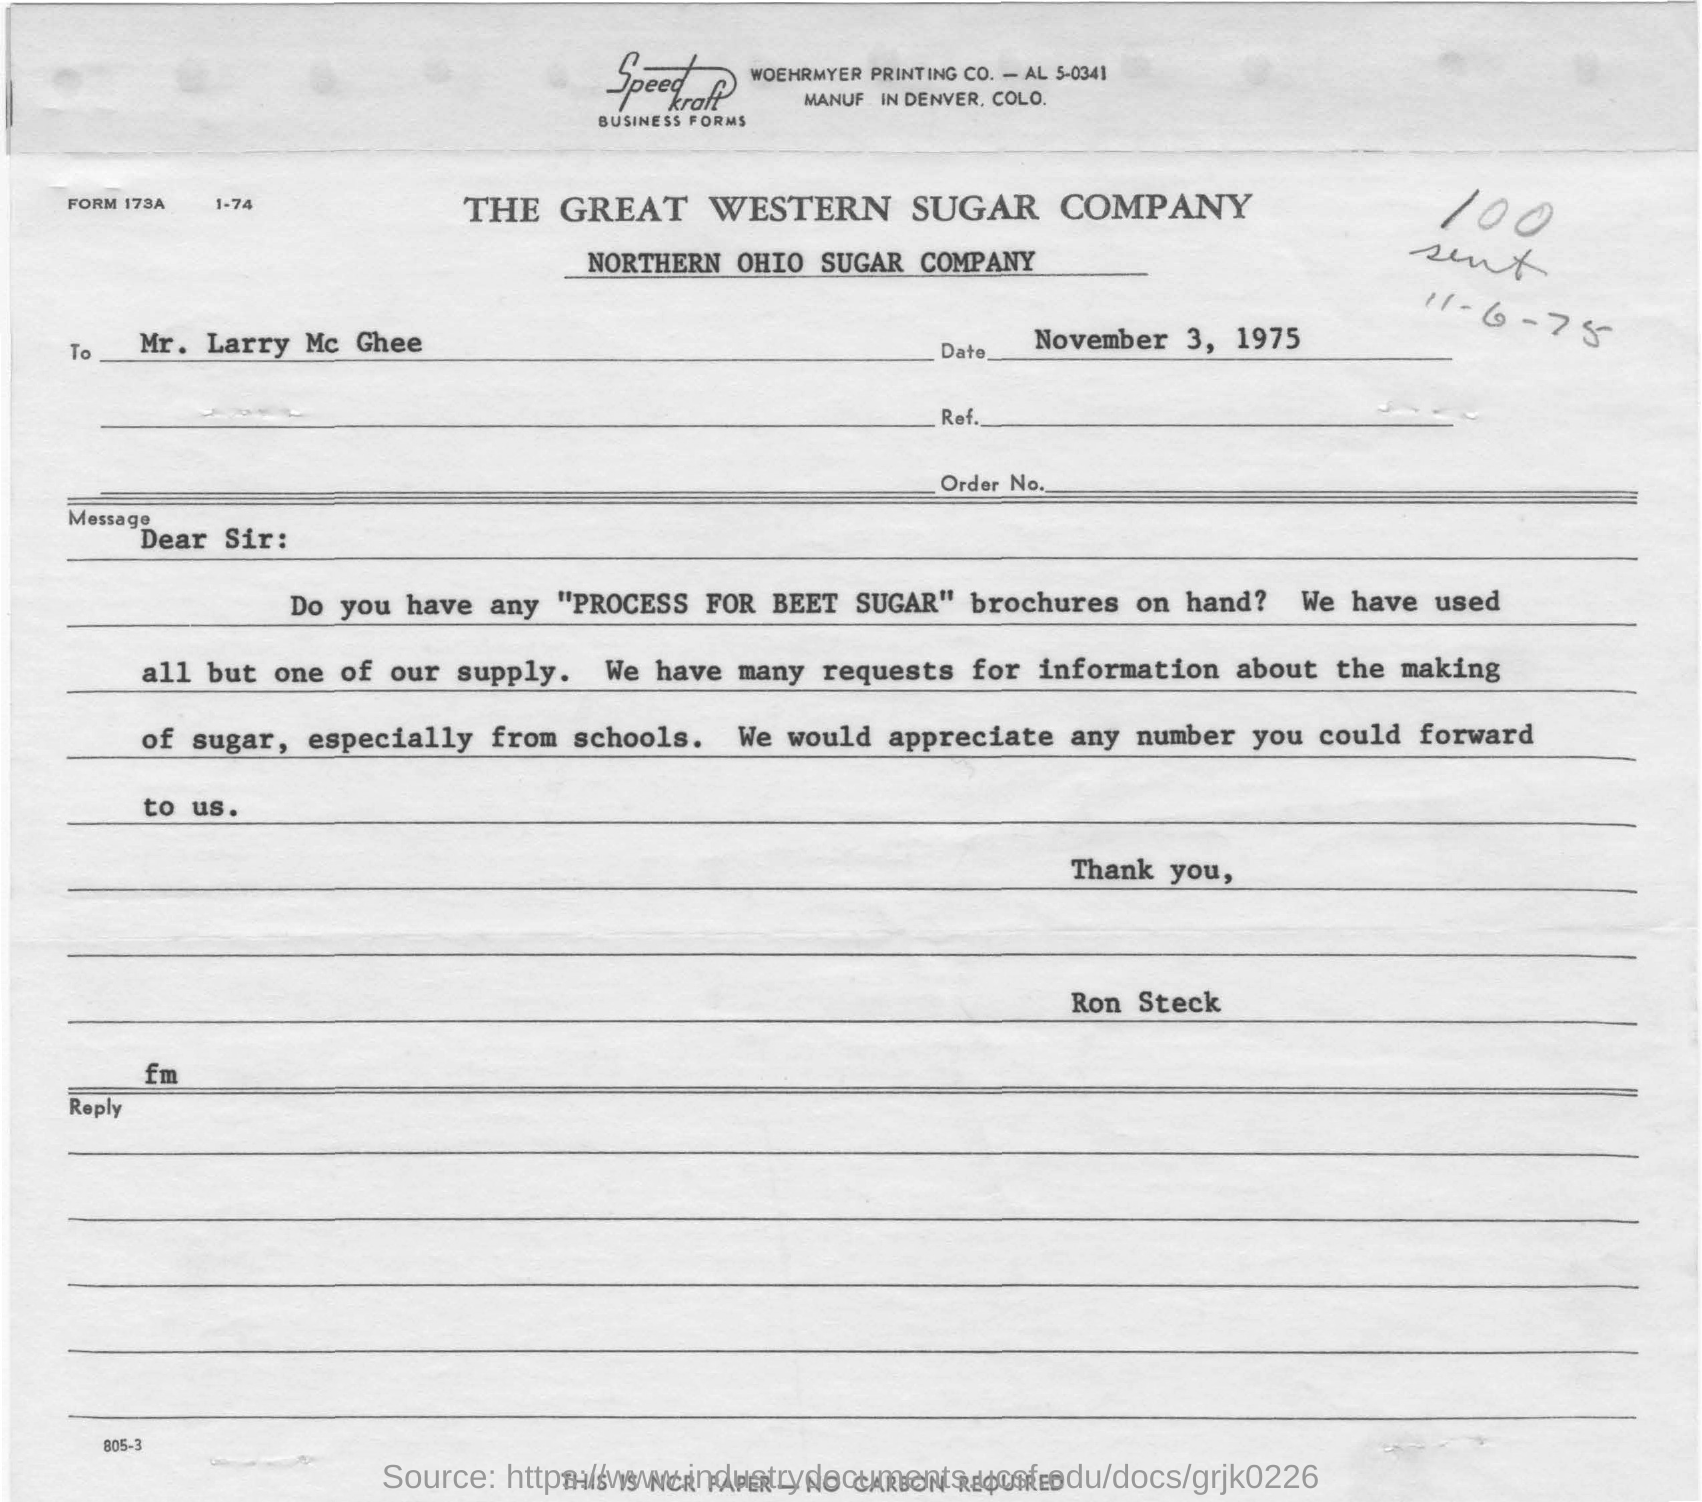Draw attention to some important aspects in this diagram. From where are they receiving numerous requests for information about the making of sugar? Schools. The great western sugar company" is the name of a sugar company. The printing company in the letter is WOEHRMYER. I am requesting brochures that provide information on the PROCESS FOR BEET SUGAR from Larry McGhee. The Northern Ohio Sugar Company is the subtitle under the title of "The Great Western Sugar Company. 